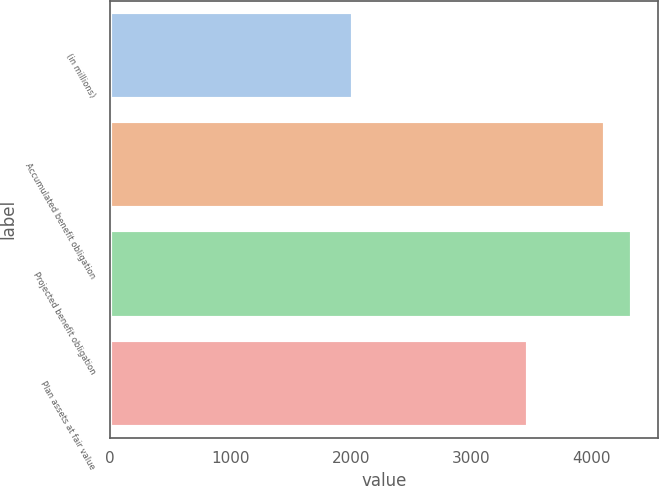Convert chart to OTSL. <chart><loc_0><loc_0><loc_500><loc_500><bar_chart><fcel>(in millions)<fcel>Accumulated benefit obligation<fcel>Projected benefit obligation<fcel>Plan assets at fair value<nl><fcel>2018<fcel>4110<fcel>4336.4<fcel>3472<nl></chart> 